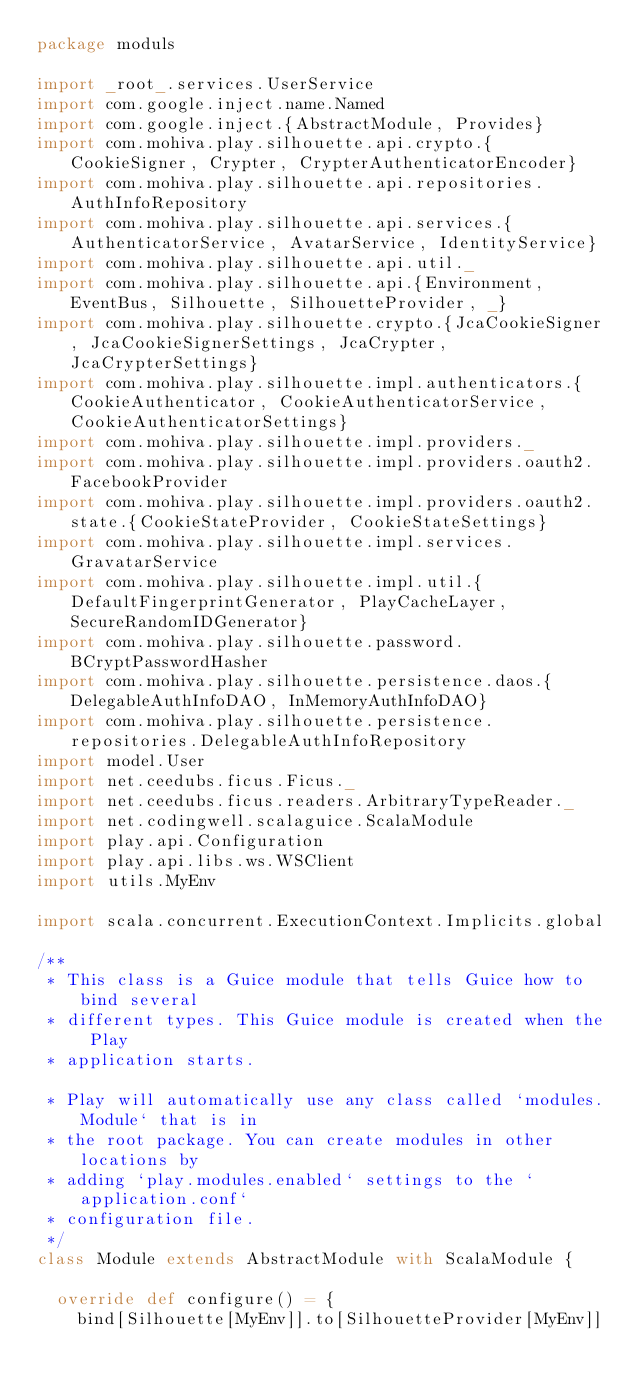<code> <loc_0><loc_0><loc_500><loc_500><_Scala_>package moduls

import _root_.services.UserService
import com.google.inject.name.Named
import com.google.inject.{AbstractModule, Provides}
import com.mohiva.play.silhouette.api.crypto.{CookieSigner, Crypter, CrypterAuthenticatorEncoder}
import com.mohiva.play.silhouette.api.repositories.AuthInfoRepository
import com.mohiva.play.silhouette.api.services.{AuthenticatorService, AvatarService, IdentityService}
import com.mohiva.play.silhouette.api.util._
import com.mohiva.play.silhouette.api.{Environment, EventBus, Silhouette, SilhouetteProvider, _}
import com.mohiva.play.silhouette.crypto.{JcaCookieSigner, JcaCookieSignerSettings, JcaCrypter, JcaCrypterSettings}
import com.mohiva.play.silhouette.impl.authenticators.{CookieAuthenticator, CookieAuthenticatorService, CookieAuthenticatorSettings}
import com.mohiva.play.silhouette.impl.providers._
import com.mohiva.play.silhouette.impl.providers.oauth2.FacebookProvider
import com.mohiva.play.silhouette.impl.providers.oauth2.state.{CookieStateProvider, CookieStateSettings}
import com.mohiva.play.silhouette.impl.services.GravatarService
import com.mohiva.play.silhouette.impl.util.{DefaultFingerprintGenerator, PlayCacheLayer, SecureRandomIDGenerator}
import com.mohiva.play.silhouette.password.BCryptPasswordHasher
import com.mohiva.play.silhouette.persistence.daos.{DelegableAuthInfoDAO, InMemoryAuthInfoDAO}
import com.mohiva.play.silhouette.persistence.repositories.DelegableAuthInfoRepository
import model.User
import net.ceedubs.ficus.Ficus._
import net.ceedubs.ficus.readers.ArbitraryTypeReader._
import net.codingwell.scalaguice.ScalaModule
import play.api.Configuration
import play.api.libs.ws.WSClient
import utils.MyEnv

import scala.concurrent.ExecutionContext.Implicits.global

/**
 * This class is a Guice module that tells Guice how to bind several
 * different types. This Guice module is created when the Play
 * application starts.

 * Play will automatically use any class called `modules.Module` that is in
 * the root package. You can create modules in other locations by
 * adding `play.modules.enabled` settings to the `application.conf`
 * configuration file.
 */
class Module extends AbstractModule with ScalaModule {

  override def configure() = {
    bind[Silhouette[MyEnv]].to[SilhouetteProvider[MyEnv]]</code> 